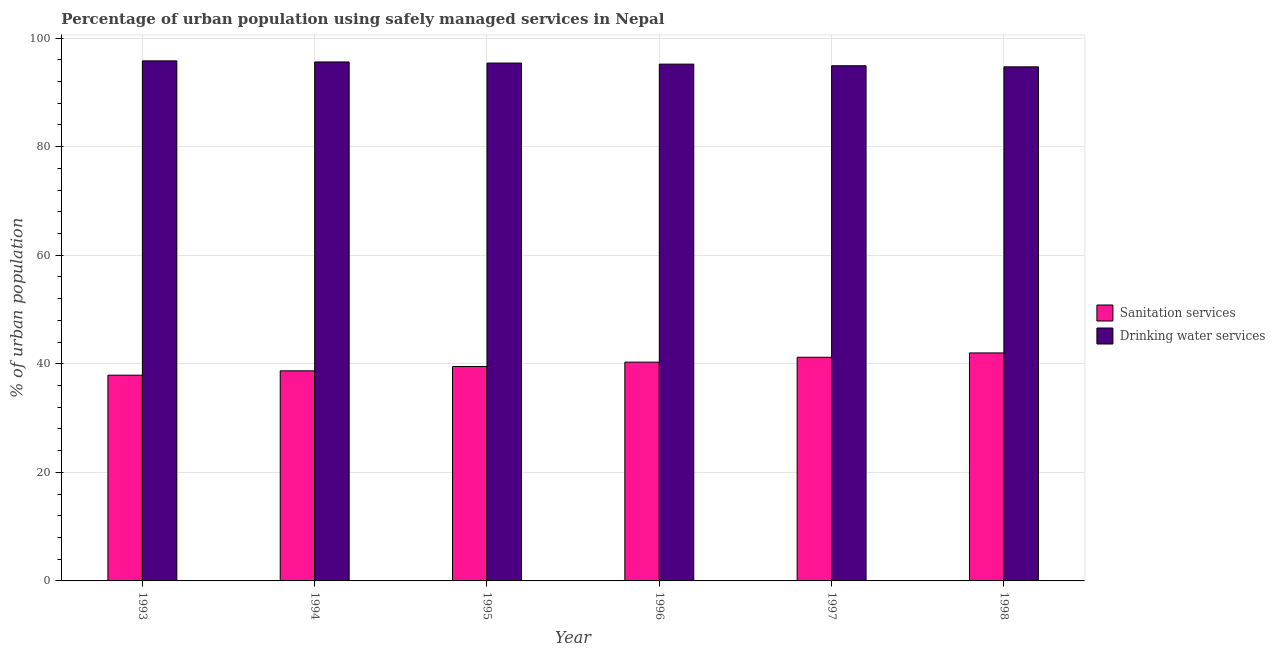How many different coloured bars are there?
Ensure brevity in your answer.  2. Are the number of bars per tick equal to the number of legend labels?
Keep it short and to the point. Yes. How many bars are there on the 2nd tick from the left?
Ensure brevity in your answer.  2. How many bars are there on the 3rd tick from the right?
Make the answer very short. 2. What is the percentage of urban population who used sanitation services in 1995?
Your answer should be compact. 39.5. Across all years, what is the maximum percentage of urban population who used drinking water services?
Offer a terse response. 95.8. Across all years, what is the minimum percentage of urban population who used sanitation services?
Your answer should be very brief. 37.9. In which year was the percentage of urban population who used sanitation services maximum?
Offer a very short reply. 1998. What is the total percentage of urban population who used drinking water services in the graph?
Offer a terse response. 571.6. What is the difference between the percentage of urban population who used drinking water services in 1996 and the percentage of urban population who used sanitation services in 1995?
Give a very brief answer. -0.2. What is the average percentage of urban population who used sanitation services per year?
Your response must be concise. 39.93. What is the ratio of the percentage of urban population who used sanitation services in 1995 to that in 1996?
Offer a terse response. 0.98. Is the percentage of urban population who used sanitation services in 1994 less than that in 1996?
Make the answer very short. Yes. What is the difference between the highest and the second highest percentage of urban population who used sanitation services?
Ensure brevity in your answer.  0.8. What is the difference between the highest and the lowest percentage of urban population who used drinking water services?
Your response must be concise. 1.1. In how many years, is the percentage of urban population who used drinking water services greater than the average percentage of urban population who used drinking water services taken over all years?
Provide a short and direct response. 3. Is the sum of the percentage of urban population who used sanitation services in 1994 and 1996 greater than the maximum percentage of urban population who used drinking water services across all years?
Keep it short and to the point. Yes. What does the 1st bar from the left in 1995 represents?
Your answer should be compact. Sanitation services. What does the 2nd bar from the right in 1997 represents?
Offer a very short reply. Sanitation services. How many bars are there?
Offer a very short reply. 12. What is the difference between two consecutive major ticks on the Y-axis?
Keep it short and to the point. 20. Are the values on the major ticks of Y-axis written in scientific E-notation?
Keep it short and to the point. No. Does the graph contain grids?
Your response must be concise. Yes. Where does the legend appear in the graph?
Provide a short and direct response. Center right. What is the title of the graph?
Give a very brief answer. Percentage of urban population using safely managed services in Nepal. Does "Old" appear as one of the legend labels in the graph?
Your response must be concise. No. What is the label or title of the X-axis?
Your response must be concise. Year. What is the label or title of the Y-axis?
Ensure brevity in your answer.  % of urban population. What is the % of urban population in Sanitation services in 1993?
Keep it short and to the point. 37.9. What is the % of urban population of Drinking water services in 1993?
Your answer should be very brief. 95.8. What is the % of urban population of Sanitation services in 1994?
Keep it short and to the point. 38.7. What is the % of urban population of Drinking water services in 1994?
Provide a succinct answer. 95.6. What is the % of urban population of Sanitation services in 1995?
Give a very brief answer. 39.5. What is the % of urban population of Drinking water services in 1995?
Give a very brief answer. 95.4. What is the % of urban population in Sanitation services in 1996?
Your answer should be compact. 40.3. What is the % of urban population of Drinking water services in 1996?
Offer a very short reply. 95.2. What is the % of urban population in Sanitation services in 1997?
Offer a very short reply. 41.2. What is the % of urban population of Drinking water services in 1997?
Keep it short and to the point. 94.9. What is the % of urban population of Drinking water services in 1998?
Make the answer very short. 94.7. Across all years, what is the maximum % of urban population of Drinking water services?
Keep it short and to the point. 95.8. Across all years, what is the minimum % of urban population in Sanitation services?
Ensure brevity in your answer.  37.9. Across all years, what is the minimum % of urban population of Drinking water services?
Make the answer very short. 94.7. What is the total % of urban population of Sanitation services in the graph?
Ensure brevity in your answer.  239.6. What is the total % of urban population in Drinking water services in the graph?
Provide a short and direct response. 571.6. What is the difference between the % of urban population of Sanitation services in 1993 and that in 1995?
Your answer should be very brief. -1.6. What is the difference between the % of urban population in Sanitation services in 1993 and that in 1996?
Give a very brief answer. -2.4. What is the difference between the % of urban population of Drinking water services in 1993 and that in 1997?
Keep it short and to the point. 0.9. What is the difference between the % of urban population of Drinking water services in 1994 and that in 1996?
Your answer should be compact. 0.4. What is the difference between the % of urban population in Sanitation services in 1994 and that in 1997?
Provide a succinct answer. -2.5. What is the difference between the % of urban population of Drinking water services in 1994 and that in 1998?
Make the answer very short. 0.9. What is the difference between the % of urban population in Sanitation services in 1995 and that in 1996?
Provide a succinct answer. -0.8. What is the difference between the % of urban population of Sanitation services in 1995 and that in 1997?
Your answer should be compact. -1.7. What is the difference between the % of urban population of Drinking water services in 1995 and that in 1998?
Provide a succinct answer. 0.7. What is the difference between the % of urban population of Sanitation services in 1996 and that in 1998?
Give a very brief answer. -1.7. What is the difference between the % of urban population of Drinking water services in 1996 and that in 1998?
Give a very brief answer. 0.5. What is the difference between the % of urban population of Sanitation services in 1993 and the % of urban population of Drinking water services in 1994?
Give a very brief answer. -57.7. What is the difference between the % of urban population of Sanitation services in 1993 and the % of urban population of Drinking water services in 1995?
Ensure brevity in your answer.  -57.5. What is the difference between the % of urban population in Sanitation services in 1993 and the % of urban population in Drinking water services in 1996?
Your response must be concise. -57.3. What is the difference between the % of urban population in Sanitation services in 1993 and the % of urban population in Drinking water services in 1997?
Provide a succinct answer. -57. What is the difference between the % of urban population in Sanitation services in 1993 and the % of urban population in Drinking water services in 1998?
Give a very brief answer. -56.8. What is the difference between the % of urban population in Sanitation services in 1994 and the % of urban population in Drinking water services in 1995?
Offer a terse response. -56.7. What is the difference between the % of urban population of Sanitation services in 1994 and the % of urban population of Drinking water services in 1996?
Keep it short and to the point. -56.5. What is the difference between the % of urban population of Sanitation services in 1994 and the % of urban population of Drinking water services in 1997?
Provide a succinct answer. -56.2. What is the difference between the % of urban population of Sanitation services in 1994 and the % of urban population of Drinking water services in 1998?
Ensure brevity in your answer.  -56. What is the difference between the % of urban population of Sanitation services in 1995 and the % of urban population of Drinking water services in 1996?
Ensure brevity in your answer.  -55.7. What is the difference between the % of urban population of Sanitation services in 1995 and the % of urban population of Drinking water services in 1997?
Your answer should be very brief. -55.4. What is the difference between the % of urban population of Sanitation services in 1995 and the % of urban population of Drinking water services in 1998?
Ensure brevity in your answer.  -55.2. What is the difference between the % of urban population of Sanitation services in 1996 and the % of urban population of Drinking water services in 1997?
Your response must be concise. -54.6. What is the difference between the % of urban population in Sanitation services in 1996 and the % of urban population in Drinking water services in 1998?
Offer a very short reply. -54.4. What is the difference between the % of urban population of Sanitation services in 1997 and the % of urban population of Drinking water services in 1998?
Make the answer very short. -53.5. What is the average % of urban population of Sanitation services per year?
Your answer should be compact. 39.93. What is the average % of urban population of Drinking water services per year?
Ensure brevity in your answer.  95.27. In the year 1993, what is the difference between the % of urban population in Sanitation services and % of urban population in Drinking water services?
Your answer should be compact. -57.9. In the year 1994, what is the difference between the % of urban population in Sanitation services and % of urban population in Drinking water services?
Provide a short and direct response. -56.9. In the year 1995, what is the difference between the % of urban population of Sanitation services and % of urban population of Drinking water services?
Offer a terse response. -55.9. In the year 1996, what is the difference between the % of urban population of Sanitation services and % of urban population of Drinking water services?
Make the answer very short. -54.9. In the year 1997, what is the difference between the % of urban population in Sanitation services and % of urban population in Drinking water services?
Ensure brevity in your answer.  -53.7. In the year 1998, what is the difference between the % of urban population of Sanitation services and % of urban population of Drinking water services?
Ensure brevity in your answer.  -52.7. What is the ratio of the % of urban population in Sanitation services in 1993 to that in 1994?
Provide a succinct answer. 0.98. What is the ratio of the % of urban population of Drinking water services in 1993 to that in 1994?
Your answer should be compact. 1. What is the ratio of the % of urban population of Sanitation services in 1993 to that in 1995?
Provide a short and direct response. 0.96. What is the ratio of the % of urban population in Sanitation services in 1993 to that in 1996?
Your answer should be compact. 0.94. What is the ratio of the % of urban population of Drinking water services in 1993 to that in 1996?
Give a very brief answer. 1.01. What is the ratio of the % of urban population of Sanitation services in 1993 to that in 1997?
Your answer should be compact. 0.92. What is the ratio of the % of urban population in Drinking water services in 1993 to that in 1997?
Offer a very short reply. 1.01. What is the ratio of the % of urban population of Sanitation services in 1993 to that in 1998?
Ensure brevity in your answer.  0.9. What is the ratio of the % of urban population in Drinking water services in 1993 to that in 1998?
Your response must be concise. 1.01. What is the ratio of the % of urban population in Sanitation services in 1994 to that in 1995?
Offer a very short reply. 0.98. What is the ratio of the % of urban population in Sanitation services in 1994 to that in 1996?
Provide a short and direct response. 0.96. What is the ratio of the % of urban population of Drinking water services in 1994 to that in 1996?
Keep it short and to the point. 1. What is the ratio of the % of urban population of Sanitation services in 1994 to that in 1997?
Your answer should be very brief. 0.94. What is the ratio of the % of urban population in Drinking water services in 1994 to that in 1997?
Your response must be concise. 1.01. What is the ratio of the % of urban population of Sanitation services in 1994 to that in 1998?
Keep it short and to the point. 0.92. What is the ratio of the % of urban population in Drinking water services in 1994 to that in 1998?
Make the answer very short. 1.01. What is the ratio of the % of urban population in Sanitation services in 1995 to that in 1996?
Ensure brevity in your answer.  0.98. What is the ratio of the % of urban population in Sanitation services in 1995 to that in 1997?
Your answer should be compact. 0.96. What is the ratio of the % of urban population in Drinking water services in 1995 to that in 1997?
Your response must be concise. 1.01. What is the ratio of the % of urban population in Sanitation services in 1995 to that in 1998?
Your answer should be very brief. 0.94. What is the ratio of the % of urban population in Drinking water services in 1995 to that in 1998?
Offer a terse response. 1.01. What is the ratio of the % of urban population in Sanitation services in 1996 to that in 1997?
Make the answer very short. 0.98. What is the ratio of the % of urban population of Sanitation services in 1996 to that in 1998?
Offer a terse response. 0.96. What is the difference between the highest and the second highest % of urban population of Sanitation services?
Provide a short and direct response. 0.8. 